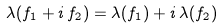<formula> <loc_0><loc_0><loc_500><loc_500>\lambda ( f _ { 1 } + i \, f _ { 2 } ) = \lambda ( f _ { 1 } ) + i \, \lambda ( f _ { 2 } )</formula> 